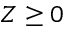<formula> <loc_0><loc_0><loc_500><loc_500>Z \geq 0</formula> 